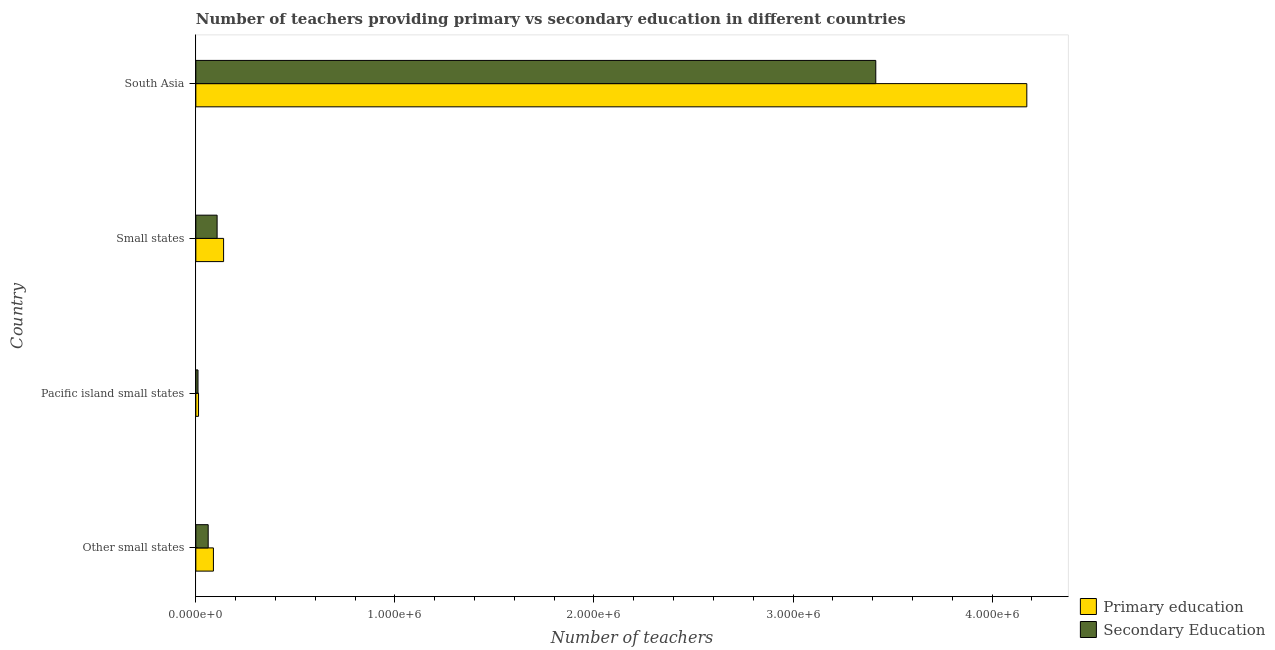How many different coloured bars are there?
Offer a very short reply. 2. How many groups of bars are there?
Provide a short and direct response. 4. Are the number of bars per tick equal to the number of legend labels?
Your response must be concise. Yes. Are the number of bars on each tick of the Y-axis equal?
Your answer should be very brief. Yes. How many bars are there on the 4th tick from the bottom?
Provide a succinct answer. 2. In how many cases, is the number of bars for a given country not equal to the number of legend labels?
Give a very brief answer. 0. What is the number of secondary teachers in South Asia?
Offer a terse response. 3.42e+06. Across all countries, what is the maximum number of secondary teachers?
Offer a terse response. 3.42e+06. Across all countries, what is the minimum number of secondary teachers?
Offer a very short reply. 1.09e+04. In which country was the number of secondary teachers minimum?
Keep it short and to the point. Pacific island small states. What is the total number of secondary teachers in the graph?
Your response must be concise. 3.60e+06. What is the difference between the number of secondary teachers in Other small states and that in Pacific island small states?
Offer a very short reply. 5.11e+04. What is the difference between the number of secondary teachers in Pacific island small states and the number of primary teachers in Small states?
Give a very brief answer. -1.29e+05. What is the average number of primary teachers per country?
Make the answer very short. 1.10e+06. What is the difference between the number of secondary teachers and number of primary teachers in Other small states?
Your answer should be compact. -2.63e+04. What is the ratio of the number of secondary teachers in Small states to that in South Asia?
Ensure brevity in your answer.  0.03. Is the number of secondary teachers in Other small states less than that in Small states?
Give a very brief answer. Yes. Is the difference between the number of secondary teachers in Other small states and Small states greater than the difference between the number of primary teachers in Other small states and Small states?
Your response must be concise. Yes. What is the difference between the highest and the second highest number of secondary teachers?
Your response must be concise. 3.31e+06. What is the difference between the highest and the lowest number of secondary teachers?
Make the answer very short. 3.40e+06. In how many countries, is the number of secondary teachers greater than the average number of secondary teachers taken over all countries?
Provide a succinct answer. 1. Is the sum of the number of secondary teachers in Other small states and Small states greater than the maximum number of primary teachers across all countries?
Give a very brief answer. No. What does the 2nd bar from the bottom in Other small states represents?
Keep it short and to the point. Secondary Education. How many countries are there in the graph?
Your answer should be very brief. 4. Does the graph contain any zero values?
Your response must be concise. No. Does the graph contain grids?
Your response must be concise. No. Where does the legend appear in the graph?
Your answer should be compact. Bottom right. How many legend labels are there?
Offer a terse response. 2. What is the title of the graph?
Your response must be concise. Number of teachers providing primary vs secondary education in different countries. What is the label or title of the X-axis?
Make the answer very short. Number of teachers. What is the Number of teachers in Primary education in Other small states?
Provide a short and direct response. 8.83e+04. What is the Number of teachers in Secondary Education in Other small states?
Your answer should be compact. 6.21e+04. What is the Number of teachers in Primary education in Pacific island small states?
Keep it short and to the point. 1.36e+04. What is the Number of teachers in Secondary Education in Pacific island small states?
Your response must be concise. 1.09e+04. What is the Number of teachers in Primary education in Small states?
Provide a succinct answer. 1.39e+05. What is the Number of teachers in Secondary Education in Small states?
Offer a very short reply. 1.07e+05. What is the Number of teachers of Primary education in South Asia?
Keep it short and to the point. 4.17e+06. What is the Number of teachers in Secondary Education in South Asia?
Your answer should be compact. 3.42e+06. Across all countries, what is the maximum Number of teachers of Primary education?
Provide a short and direct response. 4.17e+06. Across all countries, what is the maximum Number of teachers of Secondary Education?
Your answer should be compact. 3.42e+06. Across all countries, what is the minimum Number of teachers in Primary education?
Offer a very short reply. 1.36e+04. Across all countries, what is the minimum Number of teachers of Secondary Education?
Your response must be concise. 1.09e+04. What is the total Number of teachers in Primary education in the graph?
Provide a short and direct response. 4.42e+06. What is the total Number of teachers in Secondary Education in the graph?
Your response must be concise. 3.60e+06. What is the difference between the Number of teachers in Primary education in Other small states and that in Pacific island small states?
Ensure brevity in your answer.  7.48e+04. What is the difference between the Number of teachers of Secondary Education in Other small states and that in Pacific island small states?
Offer a terse response. 5.11e+04. What is the difference between the Number of teachers in Primary education in Other small states and that in Small states?
Make the answer very short. -5.11e+04. What is the difference between the Number of teachers of Secondary Education in Other small states and that in Small states?
Your answer should be compact. -4.48e+04. What is the difference between the Number of teachers of Primary education in Other small states and that in South Asia?
Your answer should be compact. -4.09e+06. What is the difference between the Number of teachers of Secondary Education in Other small states and that in South Asia?
Keep it short and to the point. -3.35e+06. What is the difference between the Number of teachers of Primary education in Pacific island small states and that in Small states?
Offer a terse response. -1.26e+05. What is the difference between the Number of teachers of Secondary Education in Pacific island small states and that in Small states?
Provide a succinct answer. -9.59e+04. What is the difference between the Number of teachers in Primary education in Pacific island small states and that in South Asia?
Ensure brevity in your answer.  -4.16e+06. What is the difference between the Number of teachers in Secondary Education in Pacific island small states and that in South Asia?
Offer a very short reply. -3.40e+06. What is the difference between the Number of teachers of Primary education in Small states and that in South Asia?
Your response must be concise. -4.03e+06. What is the difference between the Number of teachers in Secondary Education in Small states and that in South Asia?
Ensure brevity in your answer.  -3.31e+06. What is the difference between the Number of teachers in Primary education in Other small states and the Number of teachers in Secondary Education in Pacific island small states?
Your answer should be very brief. 7.74e+04. What is the difference between the Number of teachers of Primary education in Other small states and the Number of teachers of Secondary Education in Small states?
Offer a very short reply. -1.85e+04. What is the difference between the Number of teachers in Primary education in Other small states and the Number of teachers in Secondary Education in South Asia?
Keep it short and to the point. -3.33e+06. What is the difference between the Number of teachers of Primary education in Pacific island small states and the Number of teachers of Secondary Education in Small states?
Make the answer very short. -9.33e+04. What is the difference between the Number of teachers of Primary education in Pacific island small states and the Number of teachers of Secondary Education in South Asia?
Your answer should be compact. -3.40e+06. What is the difference between the Number of teachers of Primary education in Small states and the Number of teachers of Secondary Education in South Asia?
Provide a short and direct response. -3.28e+06. What is the average Number of teachers of Primary education per country?
Offer a terse response. 1.10e+06. What is the average Number of teachers in Secondary Education per country?
Offer a terse response. 8.99e+05. What is the difference between the Number of teachers in Primary education and Number of teachers in Secondary Education in Other small states?
Keep it short and to the point. 2.63e+04. What is the difference between the Number of teachers of Primary education and Number of teachers of Secondary Education in Pacific island small states?
Make the answer very short. 2643.36. What is the difference between the Number of teachers in Primary education and Number of teachers in Secondary Education in Small states?
Offer a very short reply. 3.26e+04. What is the difference between the Number of teachers in Primary education and Number of teachers in Secondary Education in South Asia?
Ensure brevity in your answer.  7.59e+05. What is the ratio of the Number of teachers of Primary education in Other small states to that in Pacific island small states?
Provide a short and direct response. 6.51. What is the ratio of the Number of teachers of Secondary Education in Other small states to that in Pacific island small states?
Offer a very short reply. 5.68. What is the ratio of the Number of teachers of Primary education in Other small states to that in Small states?
Keep it short and to the point. 0.63. What is the ratio of the Number of teachers in Secondary Education in Other small states to that in Small states?
Give a very brief answer. 0.58. What is the ratio of the Number of teachers of Primary education in Other small states to that in South Asia?
Ensure brevity in your answer.  0.02. What is the ratio of the Number of teachers of Secondary Education in Other small states to that in South Asia?
Make the answer very short. 0.02. What is the ratio of the Number of teachers of Primary education in Pacific island small states to that in Small states?
Ensure brevity in your answer.  0.1. What is the ratio of the Number of teachers of Secondary Education in Pacific island small states to that in Small states?
Ensure brevity in your answer.  0.1. What is the ratio of the Number of teachers of Primary education in Pacific island small states to that in South Asia?
Your answer should be compact. 0. What is the ratio of the Number of teachers of Secondary Education in Pacific island small states to that in South Asia?
Offer a terse response. 0. What is the ratio of the Number of teachers of Primary education in Small states to that in South Asia?
Your answer should be compact. 0.03. What is the ratio of the Number of teachers in Secondary Education in Small states to that in South Asia?
Ensure brevity in your answer.  0.03. What is the difference between the highest and the second highest Number of teachers in Primary education?
Provide a short and direct response. 4.03e+06. What is the difference between the highest and the second highest Number of teachers in Secondary Education?
Provide a short and direct response. 3.31e+06. What is the difference between the highest and the lowest Number of teachers in Primary education?
Provide a succinct answer. 4.16e+06. What is the difference between the highest and the lowest Number of teachers of Secondary Education?
Your response must be concise. 3.40e+06. 